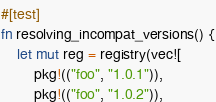<code> <loc_0><loc_0><loc_500><loc_500><_Rust_>#[test]
fn resolving_incompat_versions() {
    let mut reg = registry(vec![
        pkg!(("foo", "1.0.1")),
        pkg!(("foo", "1.0.2")),</code> 